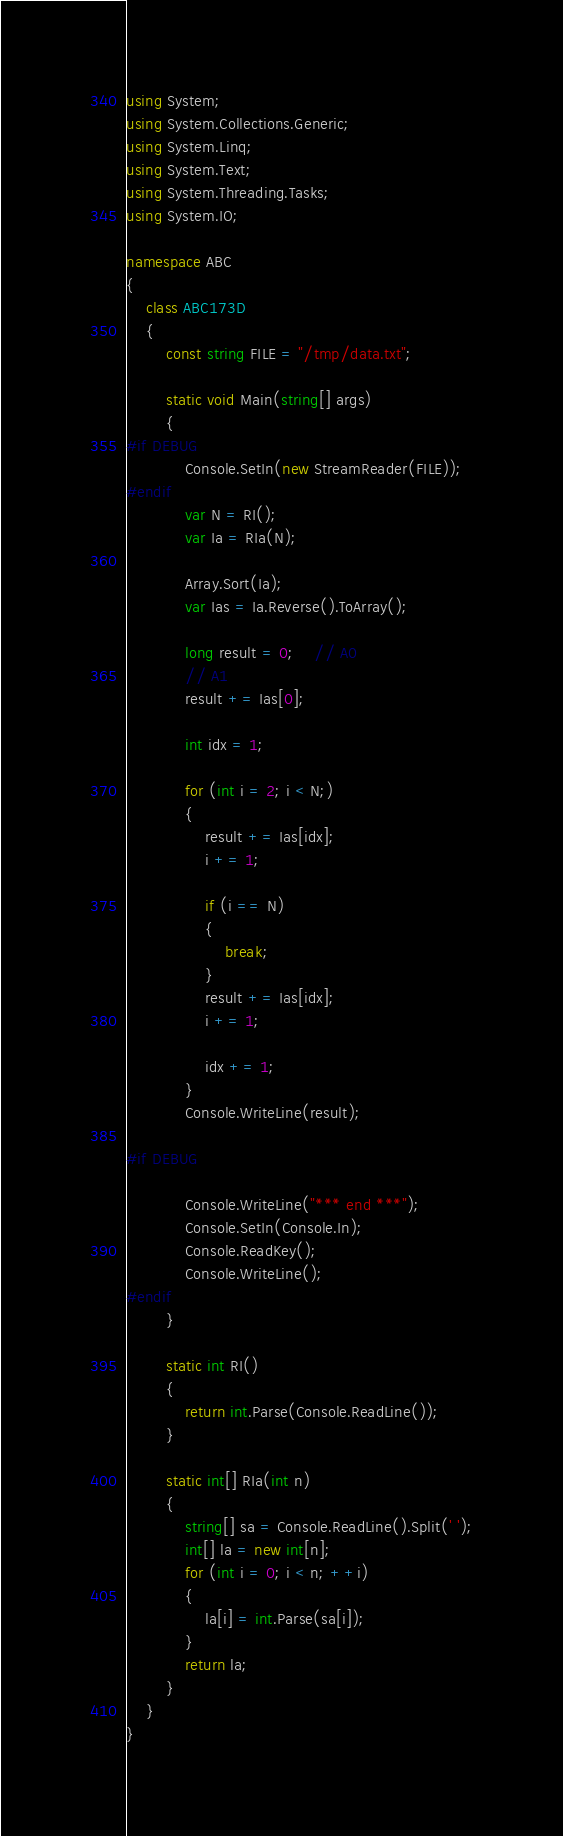<code> <loc_0><loc_0><loc_500><loc_500><_C#_>using System;
using System.Collections.Generic;
using System.Linq;
using System.Text;
using System.Threading.Tasks;
using System.IO;

namespace ABC
{
    class ABC173D
    {
        const string FILE = "/tmp/data.txt";

        static void Main(string[] args)
        {
#if DEBUG
            Console.SetIn(new StreamReader(FILE));
#endif
            var N = RI();
            var Ia = RIa(N);

            Array.Sort(Ia);
            var Ias = Ia.Reverse().ToArray();

            long result = 0;    // A0
            // A1
            result += Ias[0];

            int idx = 1;

            for (int i = 2; i < N;)
            {
                result += Ias[idx];
                i += 1;

                if (i == N)
                {
                    break;
                }
                result += Ias[idx];
                i += 1;

                idx += 1;
            }
            Console.WriteLine(result);

#if DEBUG

            Console.WriteLine("*** end ***");
            Console.SetIn(Console.In);
            Console.ReadKey();
            Console.WriteLine();
#endif
        }

        static int RI()
        {
            return int.Parse(Console.ReadLine());
        }

        static int[] RIa(int n)
        {
            string[] sa = Console.ReadLine().Split(' ');
            int[] la = new int[n];
            for (int i = 0; i < n; ++i)
            {
                la[i] = int.Parse(sa[i]);
            }
            return la;
        }
    }
}
</code> 